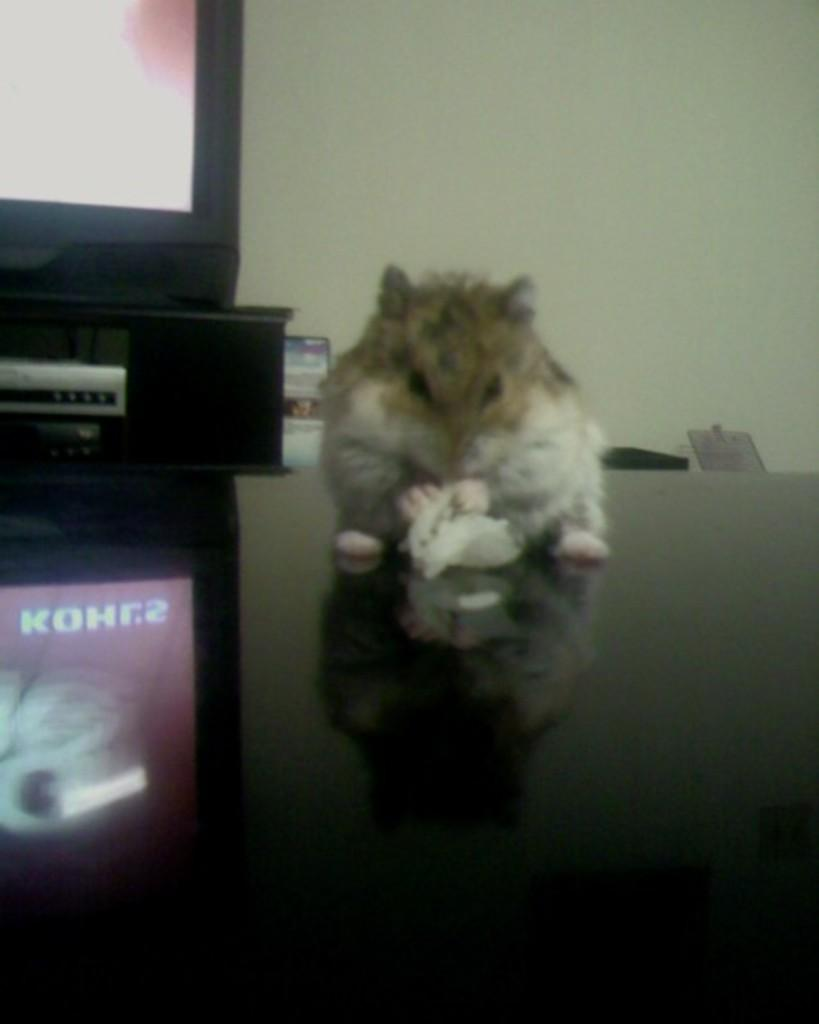What is on the glass surface in the image? There is an animal on a glass surface in the image. What other object is near the glass surface? There is a TV near the glass surface. How does the glass surface interact with the TV? The glass surface reflects the TV. What can be seen in the background of the image? There is a wall in the background of the image. How many dolls are sitting on the pie in the image? There are no dolls or pies present in the image. 